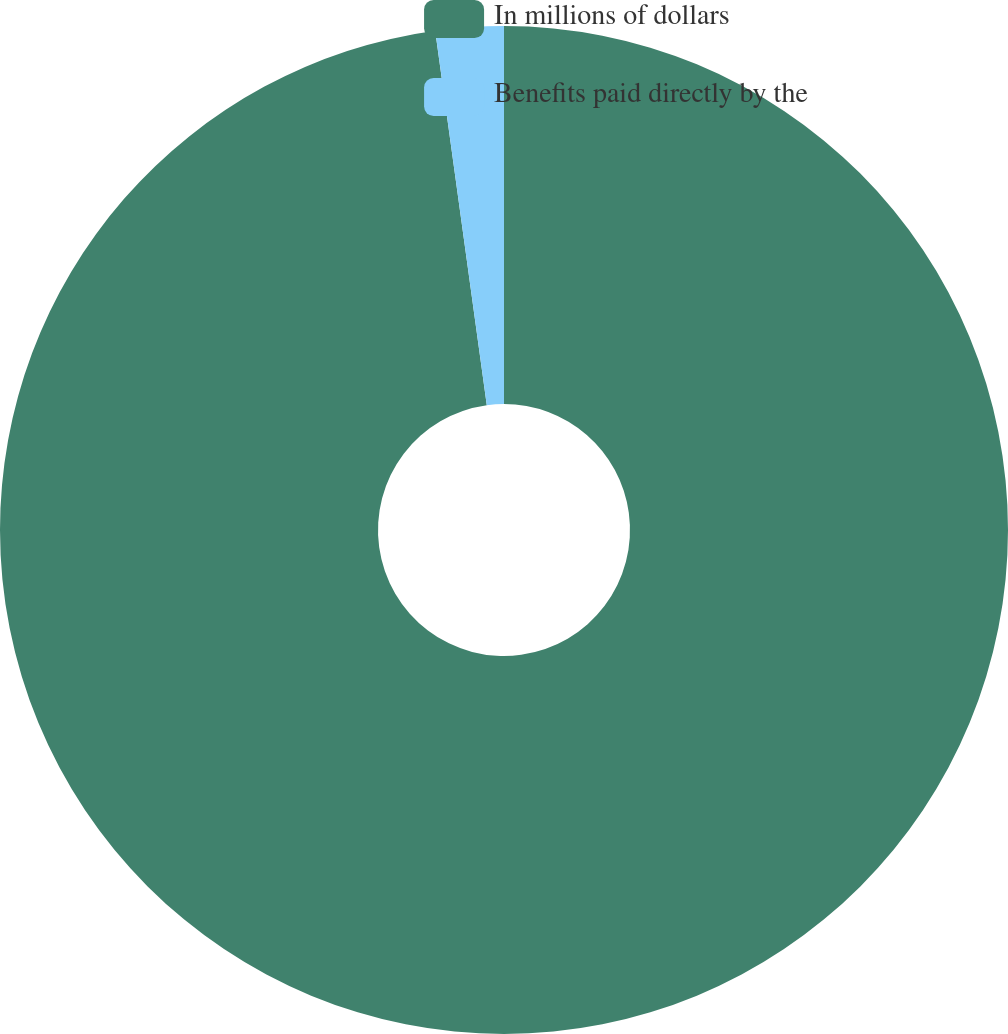Convert chart. <chart><loc_0><loc_0><loc_500><loc_500><pie_chart><fcel>In millions of dollars<fcel>Benefits paid directly by the<nl><fcel>97.82%<fcel>2.18%<nl></chart> 